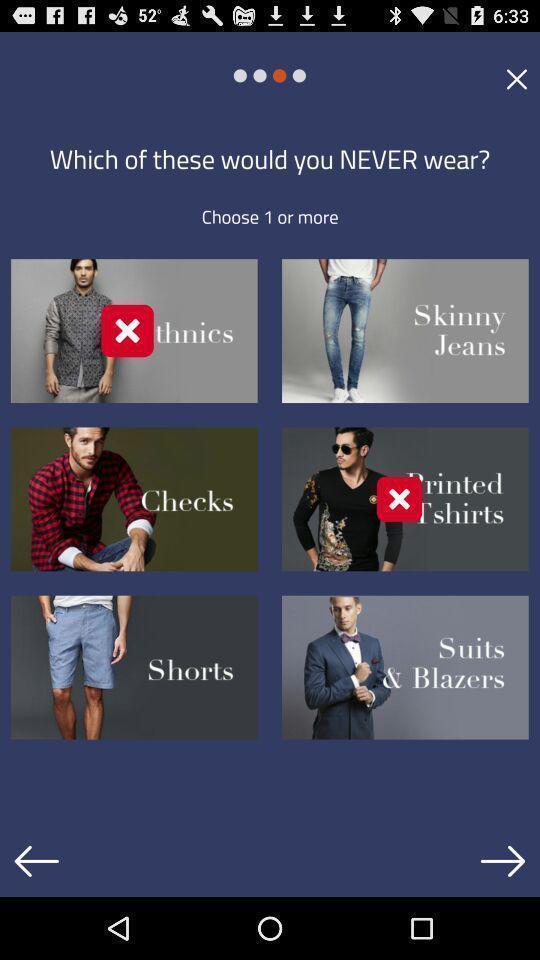Tell me about the visual elements in this screen capture. Welcome page of a shopping app. 